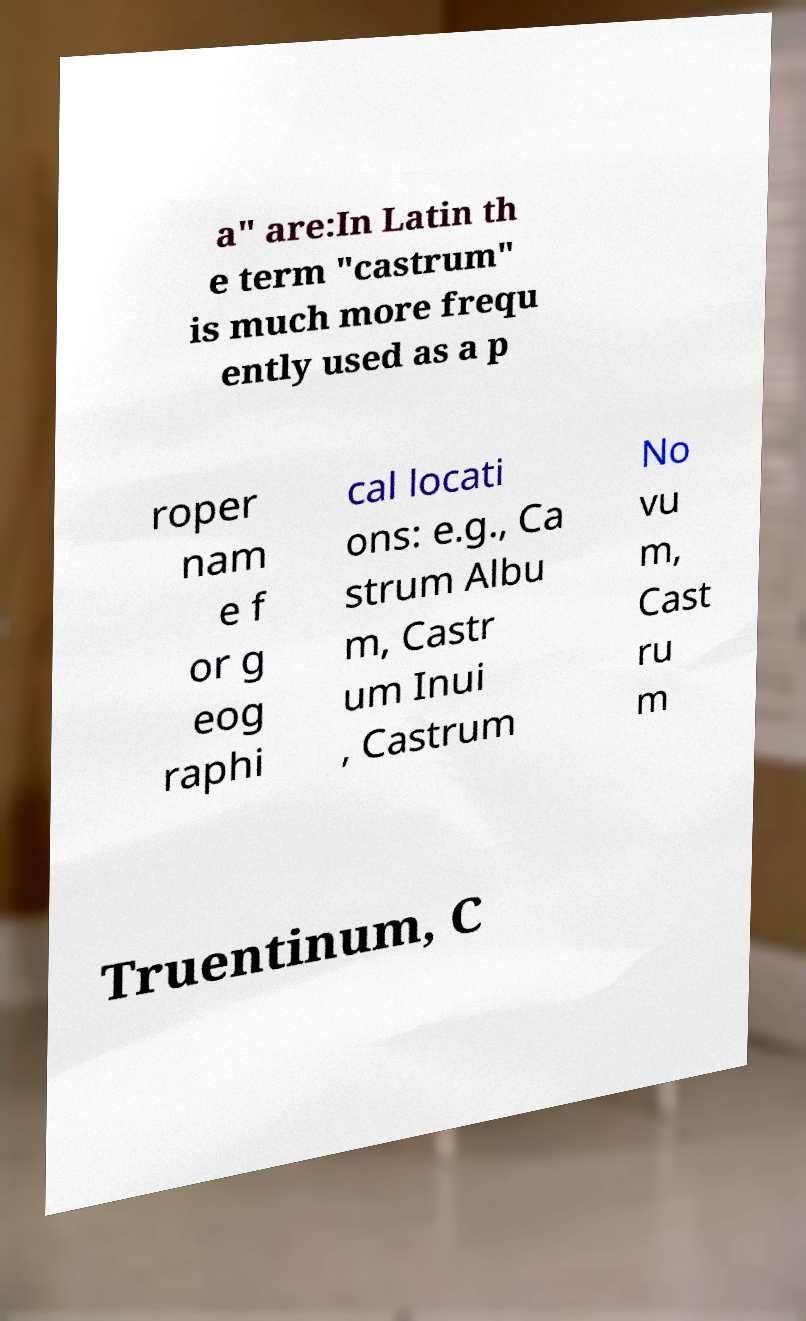I need the written content from this picture converted into text. Can you do that? a" are:In Latin th e term "castrum" is much more frequ ently used as a p roper nam e f or g eog raphi cal locati ons: e.g., Ca strum Albu m, Castr um Inui , Castrum No vu m, Cast ru m Truentinum, C 